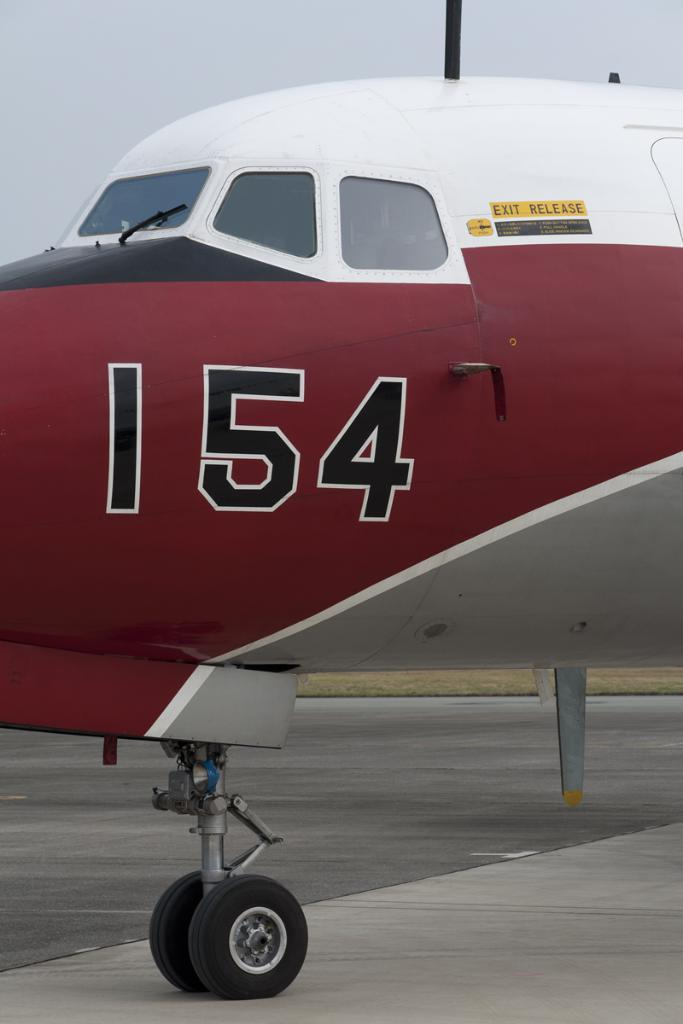What is the main subject of the image? The main subject of the image is a part of a plane. What colors can be seen on the plane? The plane has red and white colors. Are there any markings or details on the red part of the plane? Yes, there are numbers on the red part of the plane. What scientific experiment is being conducted in the image? There is no scientific experiment visible in the image; it features a part of a plane with red and white colors and numbers on the red part. How does the society depicted in the image interact with the card? There is no card or society present in the image; it only shows a part of a plane with red and white colors and numbers on the red part. 